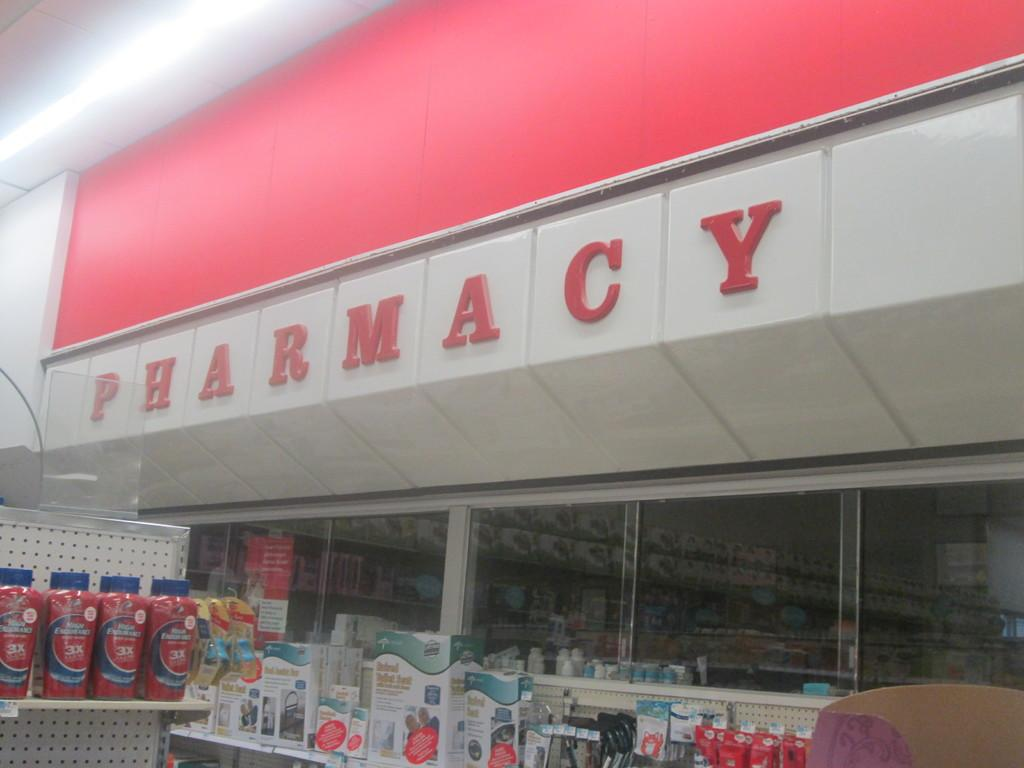What type of establishment is shown in the image? There is a pharmacy in the image. What can be seen on the shelves in the pharmacy? Bottles and boxes are arranged in racks in the pharmacy. What is visible at the top of the image? There is a wall visible at the top of the image. What is on the wall in the image? There is a red color board on the wall. How many trays are stacked on the counter in the image? There is no tray visible in the image. Is there any dust on the bottles and boxes in the image? The presence or absence of dust cannot be determined from the image. How many cats can be seen in the image? There are no cats present in the image. 